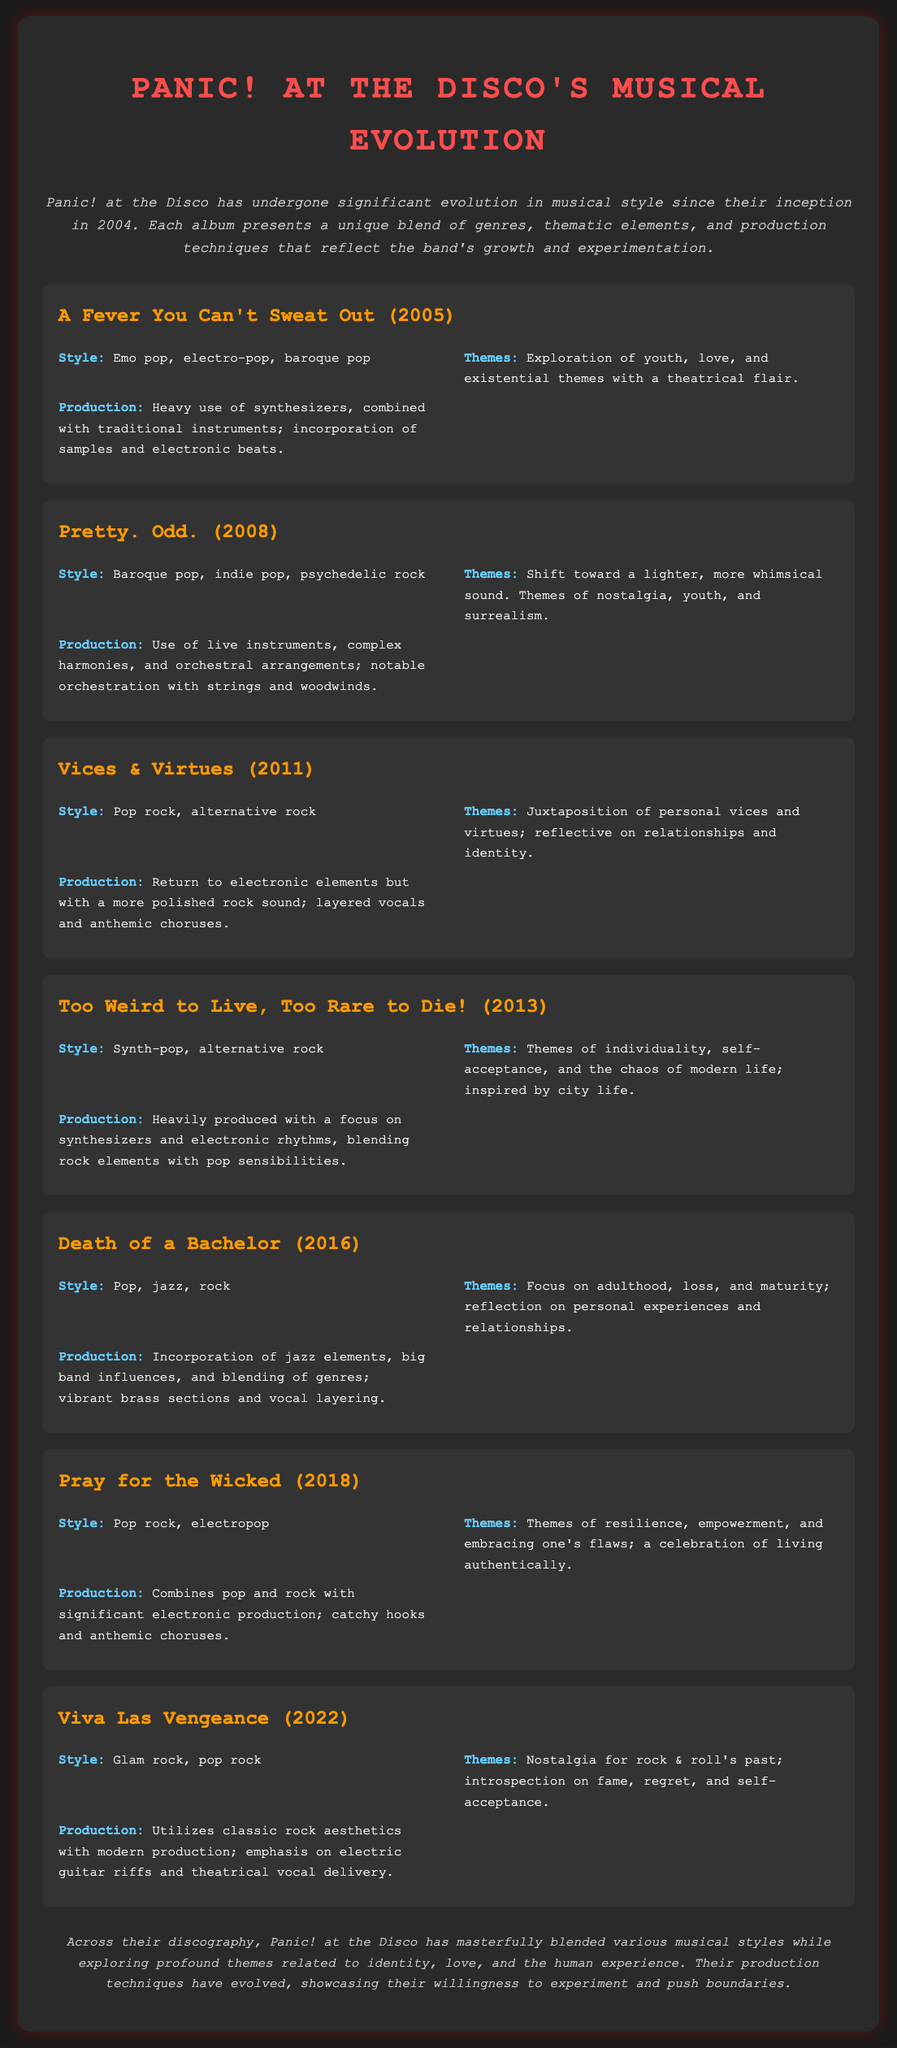What is the first album released by Panic! at the Disco? The document lists "A Fever You Can't Sweat Out" as the first album released by Panic! at the Disco in 2005.
Answer: A Fever You Can't Sweat Out Which album features themes of nostalgia, youth, and surrealism? "Pretty. Odd." is noted for its themes of nostalgia, youth, and surrealism.
Answer: Pretty. Odd What style predominates in the album "Death of a Bachelor"? The document describes the style of "Death of a Bachelor" as a blend of pop, jazz, and rock.
Answer: Pop, jazz, rock How many albums did Panic! at the Disco release before "Pray for the Wicked"? Five albums are listed before "Pray for the Wicked."
Answer: Five Which album incorporates jazz elements and big band influences? "Death of a Bachelor" is highlighted for its incorporation of jazz elements and big band influences.
Answer: Death of a Bachelor What production technique is notable in "Too Weird to Live, Too Rare to Die!"? The document notes the focus on synthesizers and electronic rhythms in "Too Weird to Live, Too Rare to Die!"
Answer: Synthesizers and electronic rhythms What is a common theme explored across Panic! at the Disco's discography? The document mentions themes related to identity, love, and the human experience as common throughout the band's work.
Answer: Identity, love, and the human experience Which album has a release year of 2022? "Viva Las Vengeance" is identified as the album released in 2022.
Answer: Viva Las Vengeance What genre did Panic! at the Disco move towards in "Viva Las Vengeance"? The document states that "Viva Las Vengeance" features glam rock and pop rock styles.
Answer: Glam rock, pop rock 